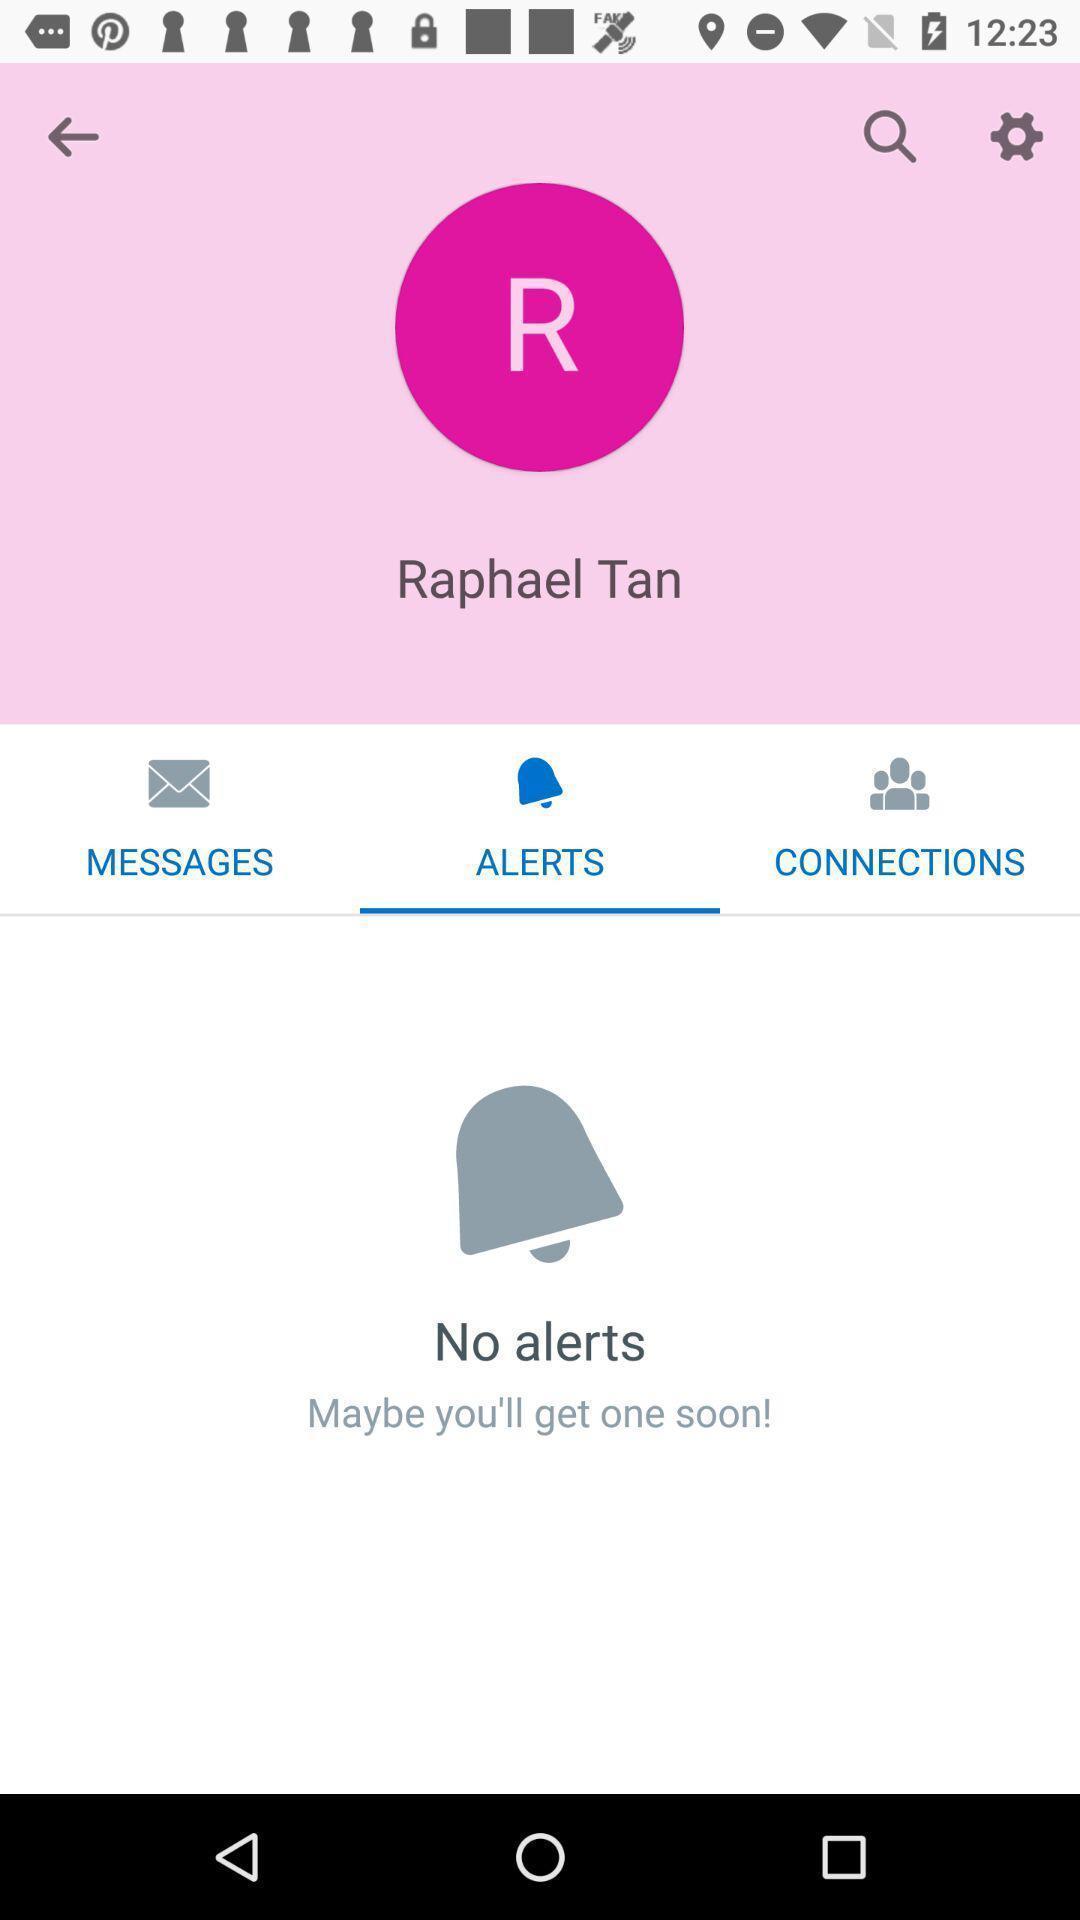Describe the content in this image. Screen displaying user profile and alert message information. 